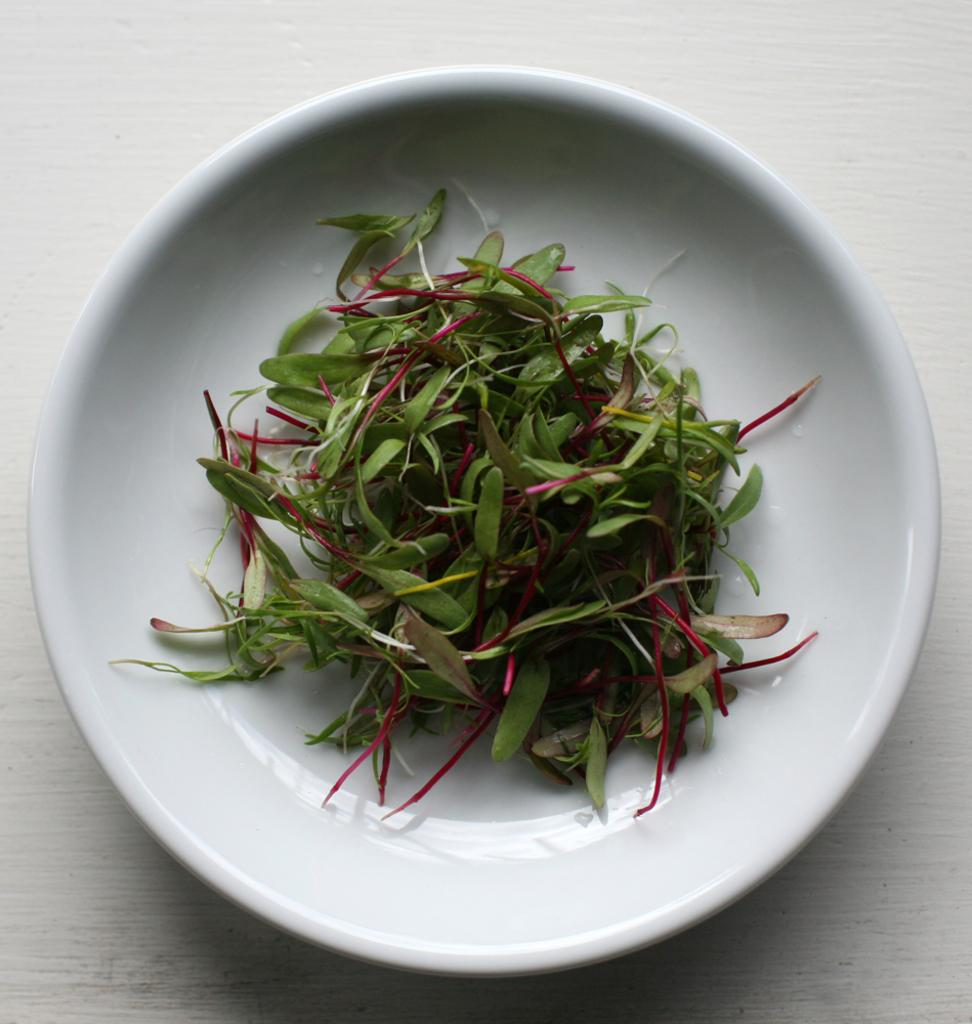What type of vegetation can be seen in the image? There are leaves in the image. How are the leaves arranged or contained in the image? The leaves are in a plate. What type of paste is being used to stick the leaves together in the image? There is no paste or indication of the leaves being stuck together in the image. 